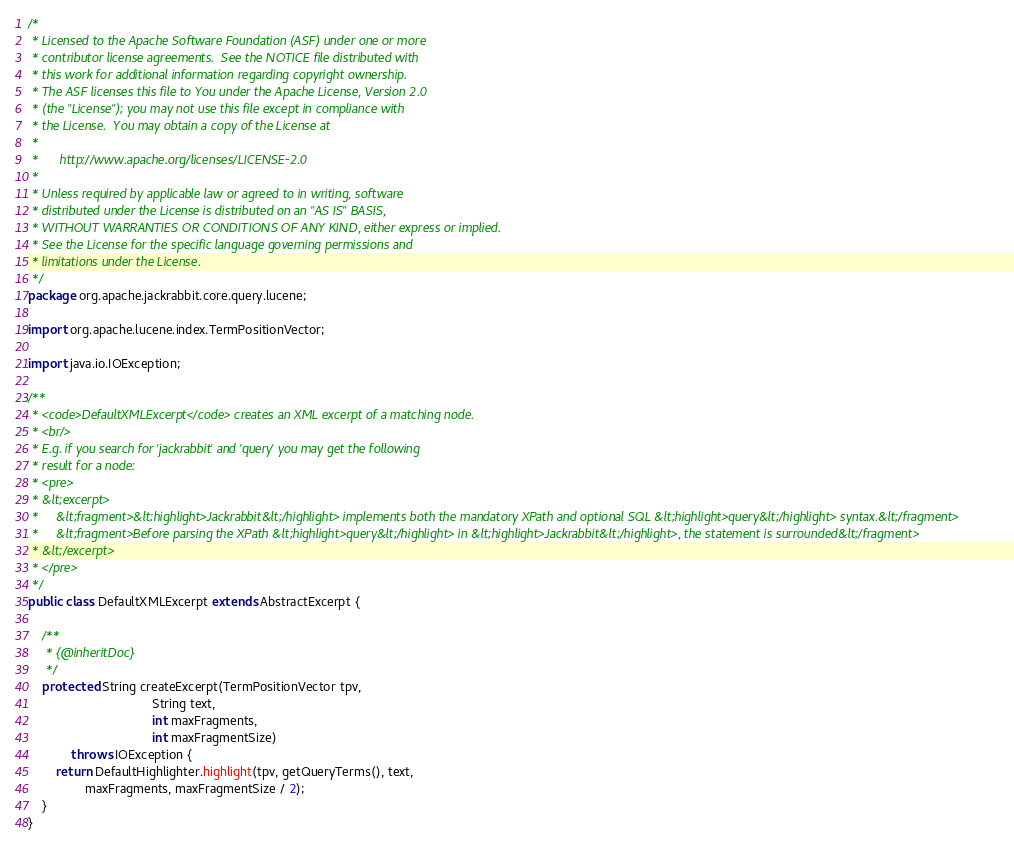Convert code to text. <code><loc_0><loc_0><loc_500><loc_500><_Java_>/*
 * Licensed to the Apache Software Foundation (ASF) under one or more
 * contributor license agreements.  See the NOTICE file distributed with
 * this work for additional information regarding copyright ownership.
 * The ASF licenses this file to You under the Apache License, Version 2.0
 * (the "License"); you may not use this file except in compliance with
 * the License.  You may obtain a copy of the License at
 *
 *      http://www.apache.org/licenses/LICENSE-2.0
 *
 * Unless required by applicable law or agreed to in writing, software
 * distributed under the License is distributed on an "AS IS" BASIS,
 * WITHOUT WARRANTIES OR CONDITIONS OF ANY KIND, either express or implied.
 * See the License for the specific language governing permissions and
 * limitations under the License.
 */
package org.apache.jackrabbit.core.query.lucene;

import org.apache.lucene.index.TermPositionVector;

import java.io.IOException;

/**
 * <code>DefaultXMLExcerpt</code> creates an XML excerpt of a matching node.
 * <br/>
 * E.g. if you search for 'jackrabbit' and 'query' you may get the following
 * result for a node:
 * <pre>
 * &lt;excerpt>
 *     &lt;fragment>&lt;highlight>Jackrabbit&lt;/highlight> implements both the mandatory XPath and optional SQL &lt;highlight>query&lt;/highlight> syntax.&lt;/fragment>
 *     &lt;fragment>Before parsing the XPath &lt;highlight>query&lt;/highlight> in &lt;highlight>Jackrabbit&lt;/highlight>, the statement is surrounded&lt;/fragment>
 * &lt;/excerpt>
 * </pre>
 */
public class DefaultXMLExcerpt extends AbstractExcerpt {

    /**
     * {@inheritDoc}
     */
    protected String createExcerpt(TermPositionVector tpv,
                                   String text,
                                   int maxFragments,
                                   int maxFragmentSize)
            throws IOException {
        return DefaultHighlighter.highlight(tpv, getQueryTerms(), text,
                maxFragments, maxFragmentSize / 2);
    }
}
</code> 